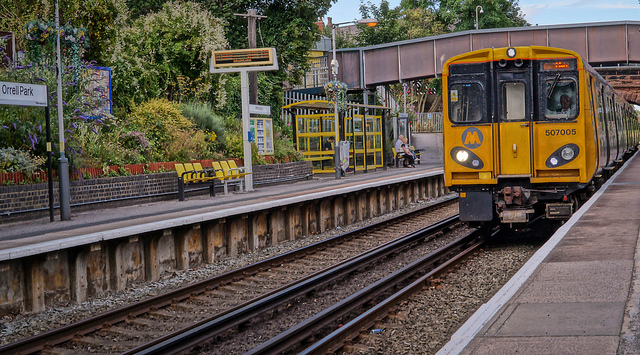Read all the text in this image. Park M 507005 